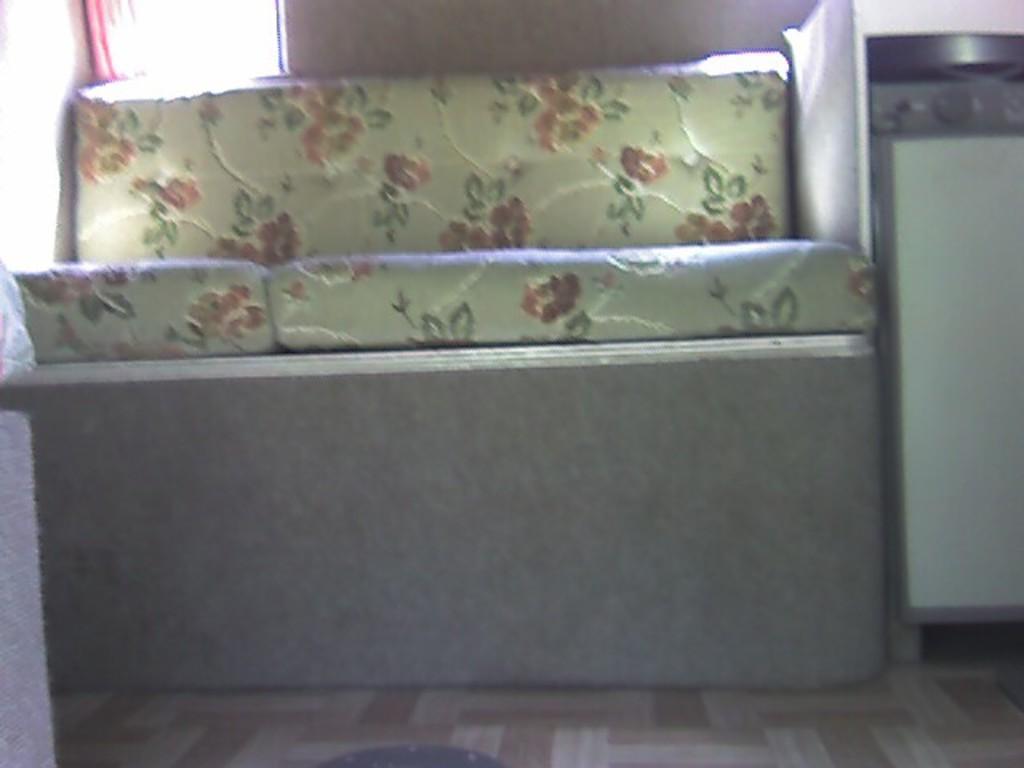Describe this image in one or two sentences. In this image there is a sofa. On the right side there is a stove. In the background there is a curtain. 